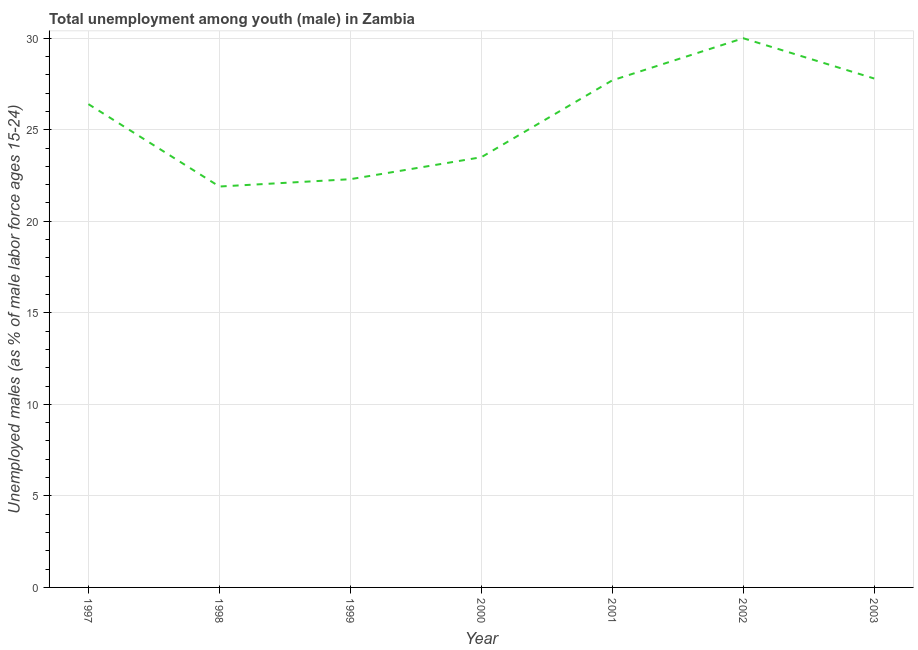What is the unemployed male youth population in 1997?
Ensure brevity in your answer.  26.4. Across all years, what is the maximum unemployed male youth population?
Provide a succinct answer. 30. Across all years, what is the minimum unemployed male youth population?
Make the answer very short. 21.9. In which year was the unemployed male youth population maximum?
Your answer should be compact. 2002. What is the sum of the unemployed male youth population?
Your answer should be very brief. 179.6. What is the difference between the unemployed male youth population in 2000 and 2003?
Provide a succinct answer. -4.3. What is the average unemployed male youth population per year?
Offer a very short reply. 25.66. What is the median unemployed male youth population?
Provide a succinct answer. 26.4. In how many years, is the unemployed male youth population greater than 12 %?
Offer a very short reply. 7. What is the ratio of the unemployed male youth population in 1999 to that in 2001?
Provide a short and direct response. 0.81. Is the unemployed male youth population in 2000 less than that in 2002?
Provide a short and direct response. Yes. Is the difference between the unemployed male youth population in 2000 and 2001 greater than the difference between any two years?
Give a very brief answer. No. What is the difference between the highest and the second highest unemployed male youth population?
Offer a very short reply. 2.2. Is the sum of the unemployed male youth population in 2001 and 2003 greater than the maximum unemployed male youth population across all years?
Provide a short and direct response. Yes. What is the difference between the highest and the lowest unemployed male youth population?
Your answer should be very brief. 8.1. How many lines are there?
Offer a terse response. 1. Are the values on the major ticks of Y-axis written in scientific E-notation?
Ensure brevity in your answer.  No. Does the graph contain any zero values?
Your answer should be compact. No. What is the title of the graph?
Provide a short and direct response. Total unemployment among youth (male) in Zambia. What is the label or title of the Y-axis?
Offer a terse response. Unemployed males (as % of male labor force ages 15-24). What is the Unemployed males (as % of male labor force ages 15-24) of 1997?
Offer a very short reply. 26.4. What is the Unemployed males (as % of male labor force ages 15-24) in 1998?
Keep it short and to the point. 21.9. What is the Unemployed males (as % of male labor force ages 15-24) in 1999?
Your response must be concise. 22.3. What is the Unemployed males (as % of male labor force ages 15-24) of 2001?
Make the answer very short. 27.7. What is the Unemployed males (as % of male labor force ages 15-24) in 2002?
Your answer should be very brief. 30. What is the Unemployed males (as % of male labor force ages 15-24) of 2003?
Give a very brief answer. 27.8. What is the difference between the Unemployed males (as % of male labor force ages 15-24) in 1997 and 1999?
Provide a succinct answer. 4.1. What is the difference between the Unemployed males (as % of male labor force ages 15-24) in 1997 and 2000?
Provide a short and direct response. 2.9. What is the difference between the Unemployed males (as % of male labor force ages 15-24) in 1997 and 2002?
Offer a terse response. -3.6. What is the difference between the Unemployed males (as % of male labor force ages 15-24) in 1997 and 2003?
Your answer should be very brief. -1.4. What is the difference between the Unemployed males (as % of male labor force ages 15-24) in 1998 and 2001?
Ensure brevity in your answer.  -5.8. What is the difference between the Unemployed males (as % of male labor force ages 15-24) in 1998 and 2002?
Your response must be concise. -8.1. What is the difference between the Unemployed males (as % of male labor force ages 15-24) in 1999 and 2000?
Ensure brevity in your answer.  -1.2. What is the difference between the Unemployed males (as % of male labor force ages 15-24) in 1999 and 2001?
Give a very brief answer. -5.4. What is the difference between the Unemployed males (as % of male labor force ages 15-24) in 1999 and 2002?
Offer a terse response. -7.7. What is the difference between the Unemployed males (as % of male labor force ages 15-24) in 1999 and 2003?
Ensure brevity in your answer.  -5.5. What is the difference between the Unemployed males (as % of male labor force ages 15-24) in 2000 and 2001?
Offer a terse response. -4.2. What is the difference between the Unemployed males (as % of male labor force ages 15-24) in 2000 and 2002?
Make the answer very short. -6.5. What is the difference between the Unemployed males (as % of male labor force ages 15-24) in 2000 and 2003?
Your answer should be very brief. -4.3. What is the difference between the Unemployed males (as % of male labor force ages 15-24) in 2001 and 2003?
Keep it short and to the point. -0.1. What is the difference between the Unemployed males (as % of male labor force ages 15-24) in 2002 and 2003?
Give a very brief answer. 2.2. What is the ratio of the Unemployed males (as % of male labor force ages 15-24) in 1997 to that in 1998?
Your answer should be compact. 1.21. What is the ratio of the Unemployed males (as % of male labor force ages 15-24) in 1997 to that in 1999?
Your answer should be very brief. 1.18. What is the ratio of the Unemployed males (as % of male labor force ages 15-24) in 1997 to that in 2000?
Provide a succinct answer. 1.12. What is the ratio of the Unemployed males (as % of male labor force ages 15-24) in 1997 to that in 2001?
Keep it short and to the point. 0.95. What is the ratio of the Unemployed males (as % of male labor force ages 15-24) in 1997 to that in 2002?
Your answer should be very brief. 0.88. What is the ratio of the Unemployed males (as % of male labor force ages 15-24) in 1997 to that in 2003?
Your response must be concise. 0.95. What is the ratio of the Unemployed males (as % of male labor force ages 15-24) in 1998 to that in 2000?
Your answer should be very brief. 0.93. What is the ratio of the Unemployed males (as % of male labor force ages 15-24) in 1998 to that in 2001?
Make the answer very short. 0.79. What is the ratio of the Unemployed males (as % of male labor force ages 15-24) in 1998 to that in 2002?
Your answer should be very brief. 0.73. What is the ratio of the Unemployed males (as % of male labor force ages 15-24) in 1998 to that in 2003?
Provide a short and direct response. 0.79. What is the ratio of the Unemployed males (as % of male labor force ages 15-24) in 1999 to that in 2000?
Your answer should be very brief. 0.95. What is the ratio of the Unemployed males (as % of male labor force ages 15-24) in 1999 to that in 2001?
Offer a terse response. 0.81. What is the ratio of the Unemployed males (as % of male labor force ages 15-24) in 1999 to that in 2002?
Offer a terse response. 0.74. What is the ratio of the Unemployed males (as % of male labor force ages 15-24) in 1999 to that in 2003?
Keep it short and to the point. 0.8. What is the ratio of the Unemployed males (as % of male labor force ages 15-24) in 2000 to that in 2001?
Provide a short and direct response. 0.85. What is the ratio of the Unemployed males (as % of male labor force ages 15-24) in 2000 to that in 2002?
Offer a very short reply. 0.78. What is the ratio of the Unemployed males (as % of male labor force ages 15-24) in 2000 to that in 2003?
Offer a very short reply. 0.84. What is the ratio of the Unemployed males (as % of male labor force ages 15-24) in 2001 to that in 2002?
Provide a short and direct response. 0.92. What is the ratio of the Unemployed males (as % of male labor force ages 15-24) in 2002 to that in 2003?
Offer a very short reply. 1.08. 